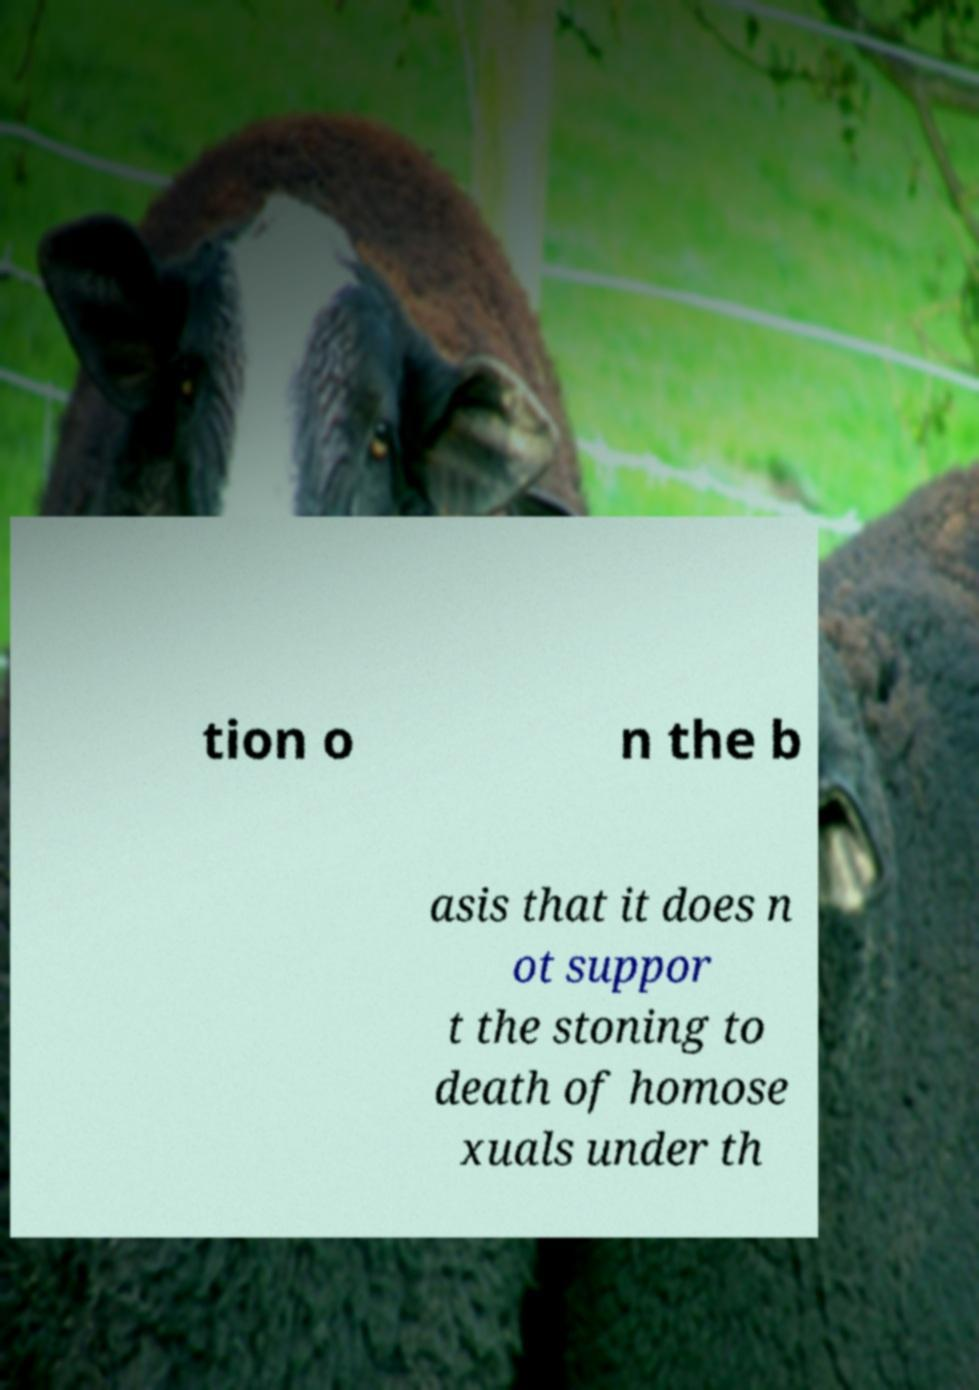Could you assist in decoding the text presented in this image and type it out clearly? tion o n the b asis that it does n ot suppor t the stoning to death of homose xuals under th 